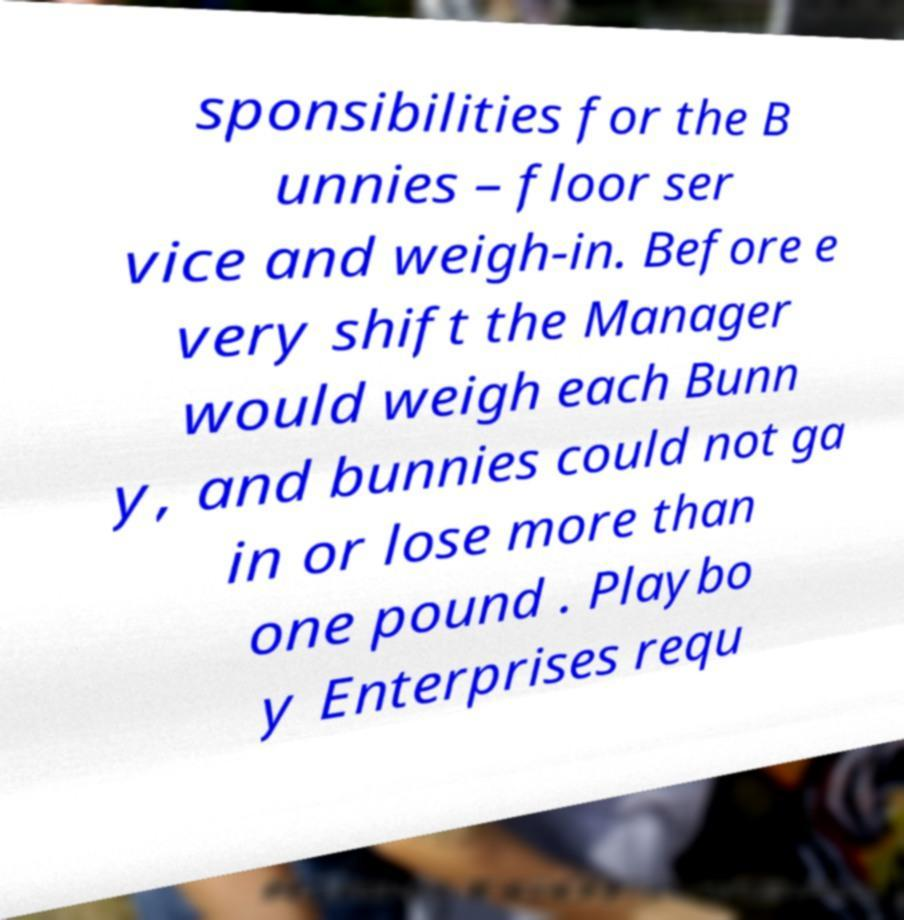Can you accurately transcribe the text from the provided image for me? sponsibilities for the B unnies – floor ser vice and weigh-in. Before e very shift the Manager would weigh each Bunn y, and bunnies could not ga in or lose more than one pound . Playbo y Enterprises requ 